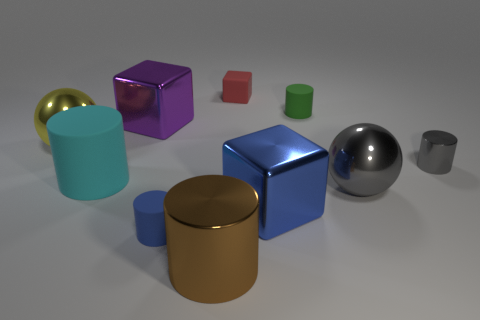Is the cyan thing the same size as the blue shiny thing?
Give a very brief answer. Yes. Are there any big gray cylinders that have the same material as the large gray thing?
Provide a short and direct response. No. The shiny sphere that is the same color as the tiny metal thing is what size?
Your response must be concise. Large. How many objects are both to the left of the blue matte object and on the right side of the brown cylinder?
Provide a succinct answer. 0. There is a blue object to the left of the blue metal thing; what is its material?
Keep it short and to the point. Rubber. How many big cubes have the same color as the tiny block?
Give a very brief answer. 0. There is a yellow thing that is the same material as the big blue object; what is its size?
Your response must be concise. Large. What number of objects are blue metallic blocks or small objects?
Ensure brevity in your answer.  5. There is a tiny rubber cylinder in front of the large gray shiny object; what is its color?
Keep it short and to the point. Blue. There is another shiny thing that is the same shape as the big purple metallic thing; what size is it?
Offer a very short reply. Large. 